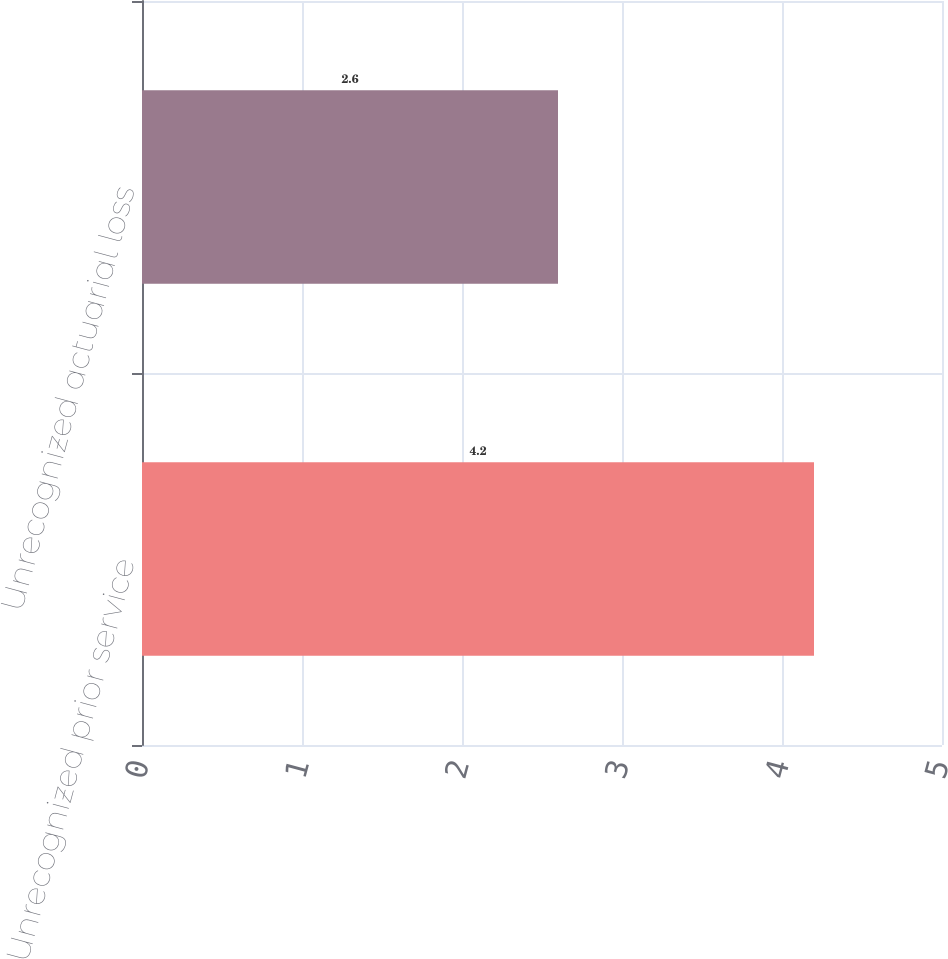Convert chart. <chart><loc_0><loc_0><loc_500><loc_500><bar_chart><fcel>Unrecognized prior service<fcel>Unrecognized actuarial loss<nl><fcel>4.2<fcel>2.6<nl></chart> 